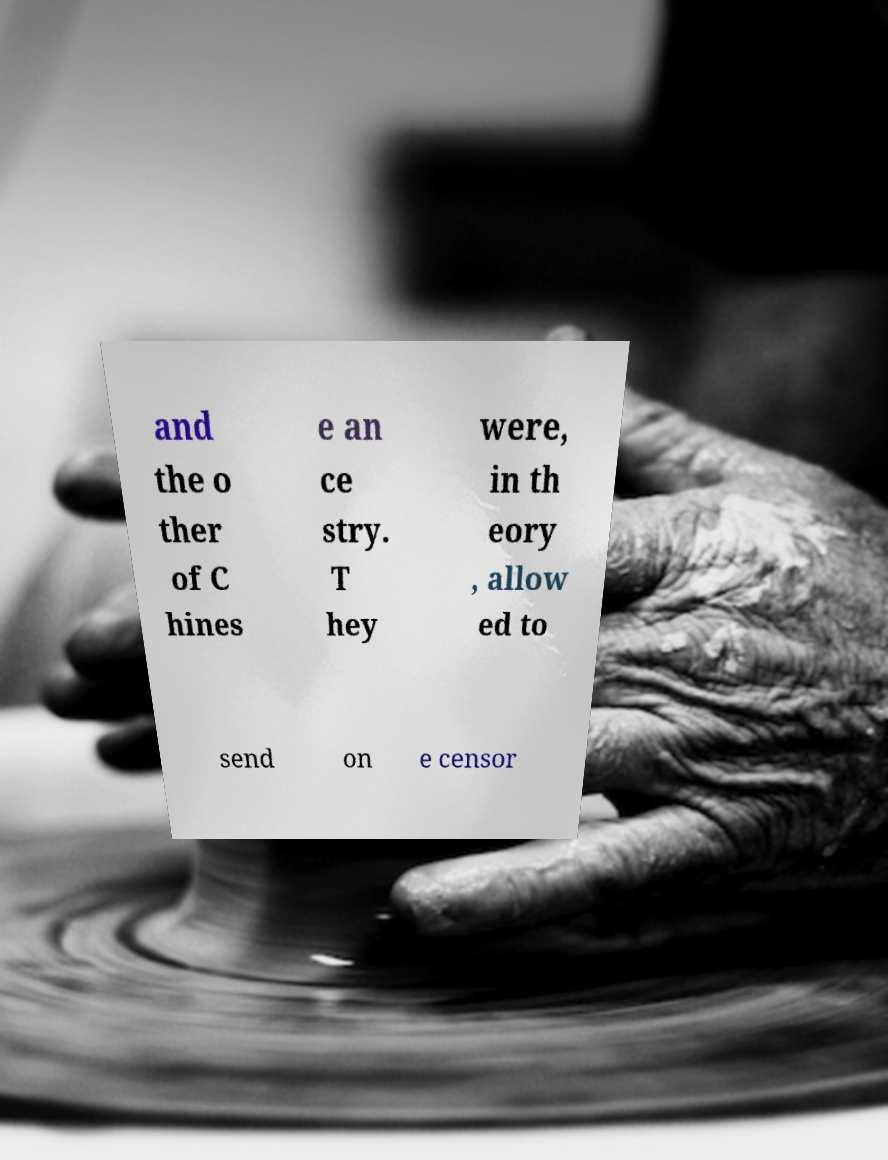There's text embedded in this image that I need extracted. Can you transcribe it verbatim? and the o ther of C hines e an ce stry. T hey were, in th eory , allow ed to send on e censor 